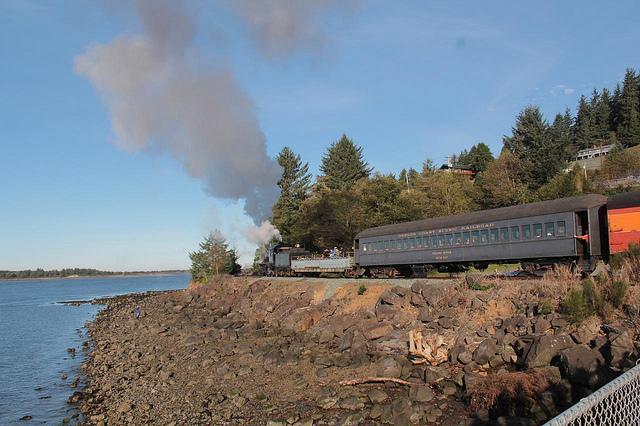How many people are wearing an orange tee shirt?
Give a very brief answer. 0. 